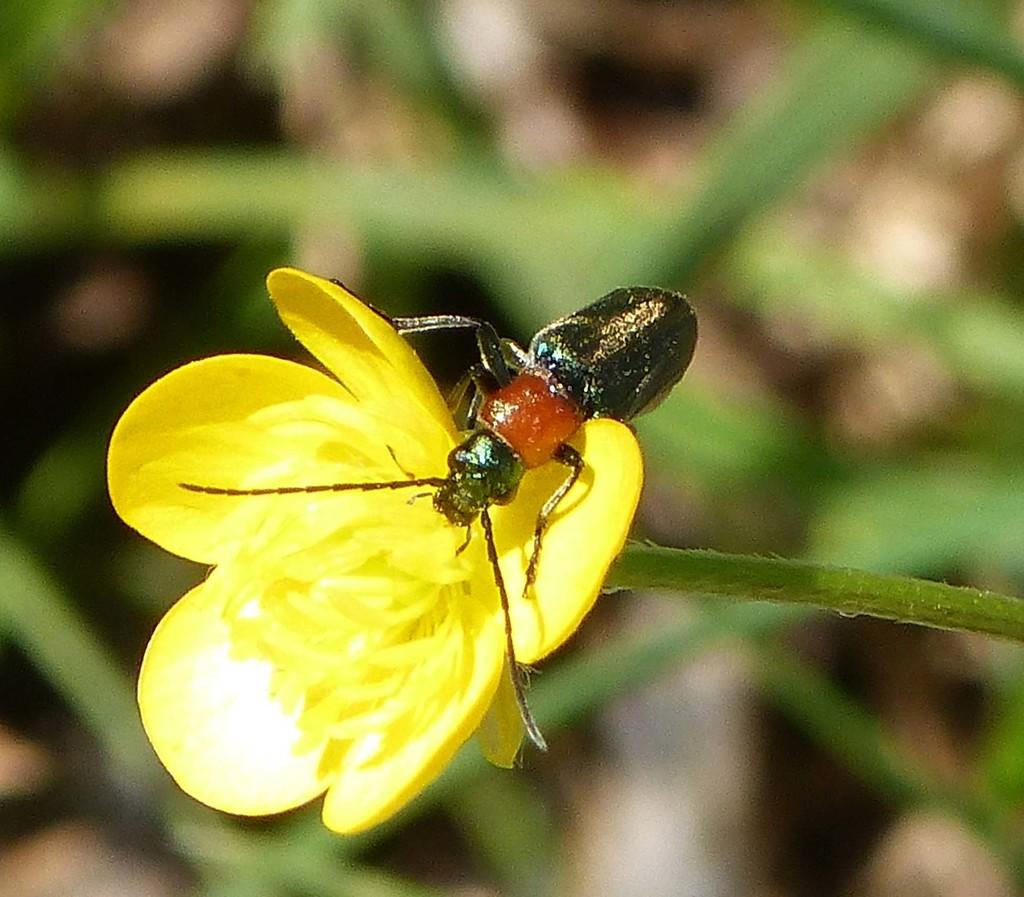What is the main subject of the image? There is an insect present on a flower in the image. Can you describe the background of the image? The background of the image is blurry. What type of apparatus is being used to catch fish in the image? There is no apparatus or fishing activity present in the image; it features an insect on a flower. Where is the lunchroom located in the image? There is no lunchroom present in the image; it features an insect on a flower. 